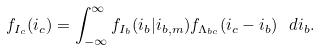Convert formula to latex. <formula><loc_0><loc_0><loc_500><loc_500>f _ { I _ { c } } ( i _ { c } ) = \int _ { - \infty } ^ { \infty } f _ { I _ { b } } ( i _ { b } | i _ { b , m } ) f _ { \Lambda _ { b c } } ( i _ { c } - i _ { b } ) \ d i _ { b } .</formula> 